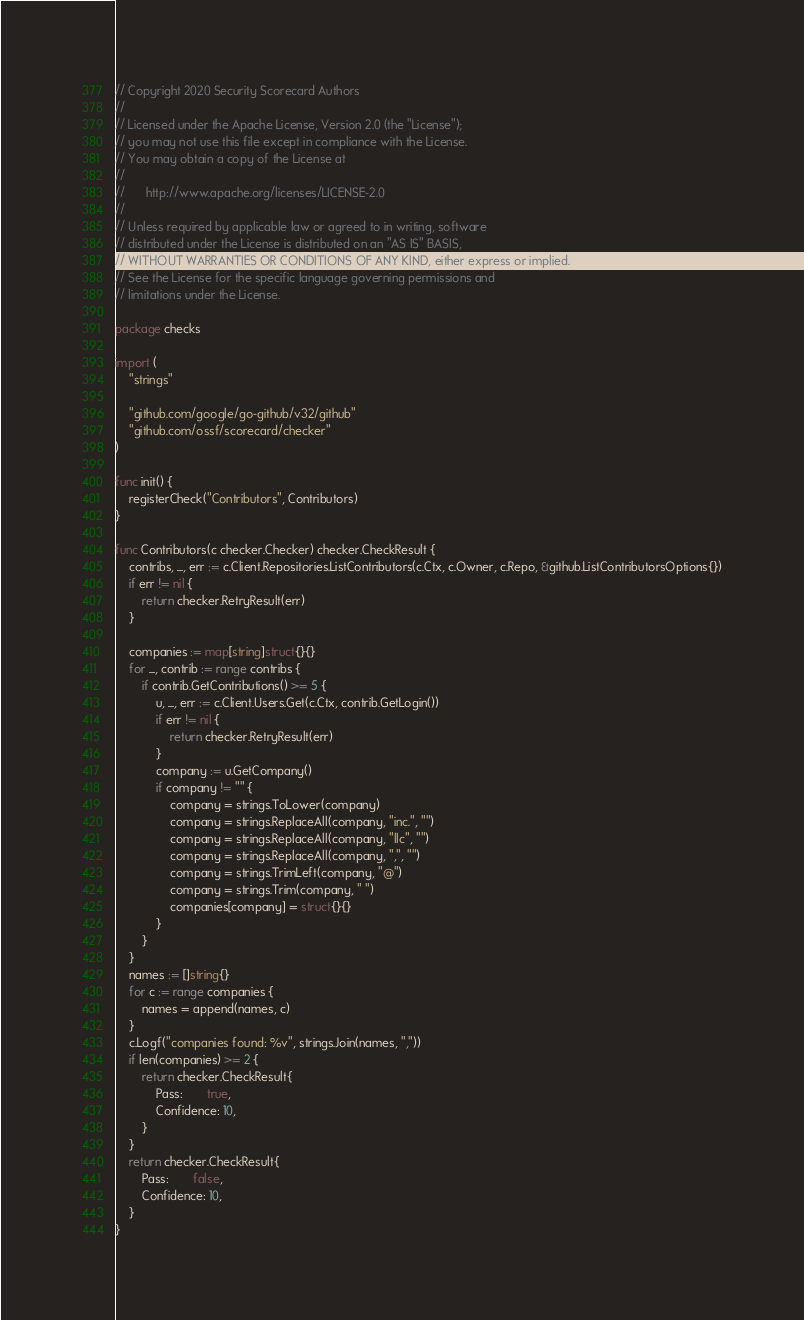<code> <loc_0><loc_0><loc_500><loc_500><_Go_>// Copyright 2020 Security Scorecard Authors
//
// Licensed under the Apache License, Version 2.0 (the "License");
// you may not use this file except in compliance with the License.
// You may obtain a copy of the License at
//
//      http://www.apache.org/licenses/LICENSE-2.0
//
// Unless required by applicable law or agreed to in writing, software
// distributed under the License is distributed on an "AS IS" BASIS,
// WITHOUT WARRANTIES OR CONDITIONS OF ANY KIND, either express or implied.
// See the License for the specific language governing permissions and
// limitations under the License.

package checks

import (
	"strings"

	"github.com/google/go-github/v32/github"
	"github.com/ossf/scorecard/checker"
)

func init() {
	registerCheck("Contributors", Contributors)
}

func Contributors(c checker.Checker) checker.CheckResult {
	contribs, _, err := c.Client.Repositories.ListContributors(c.Ctx, c.Owner, c.Repo, &github.ListContributorsOptions{})
	if err != nil {
		return checker.RetryResult(err)
	}

	companies := map[string]struct{}{}
	for _, contrib := range contribs {
		if contrib.GetContributions() >= 5 {
			u, _, err := c.Client.Users.Get(c.Ctx, contrib.GetLogin())
			if err != nil {
				return checker.RetryResult(err)
			}
			company := u.GetCompany()
			if company != "" {
				company = strings.ToLower(company)
				company = strings.ReplaceAll(company, "inc.", "")
				company = strings.ReplaceAll(company, "llc", "")
				company = strings.ReplaceAll(company, ",", "")
				company = strings.TrimLeft(company, "@")
				company = strings.Trim(company, " ")
				companies[company] = struct{}{}
			}
		}
	}
	names := []string{}
	for c := range companies {
		names = append(names, c)
	}
	c.Logf("companies found: %v", strings.Join(names, ","))
	if len(companies) >= 2 {
		return checker.CheckResult{
			Pass:       true,
			Confidence: 10,
		}
	}
	return checker.CheckResult{
		Pass:       false,
		Confidence: 10,
	}
}
</code> 